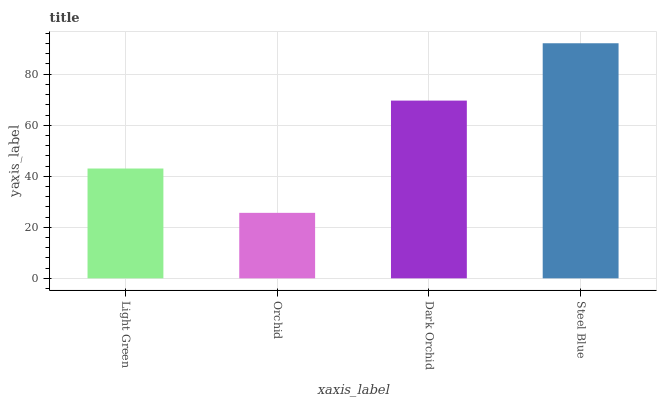Is Dark Orchid the minimum?
Answer yes or no. No. Is Dark Orchid the maximum?
Answer yes or no. No. Is Dark Orchid greater than Orchid?
Answer yes or no. Yes. Is Orchid less than Dark Orchid?
Answer yes or no. Yes. Is Orchid greater than Dark Orchid?
Answer yes or no. No. Is Dark Orchid less than Orchid?
Answer yes or no. No. Is Dark Orchid the high median?
Answer yes or no. Yes. Is Light Green the low median?
Answer yes or no. Yes. Is Steel Blue the high median?
Answer yes or no. No. Is Orchid the low median?
Answer yes or no. No. 